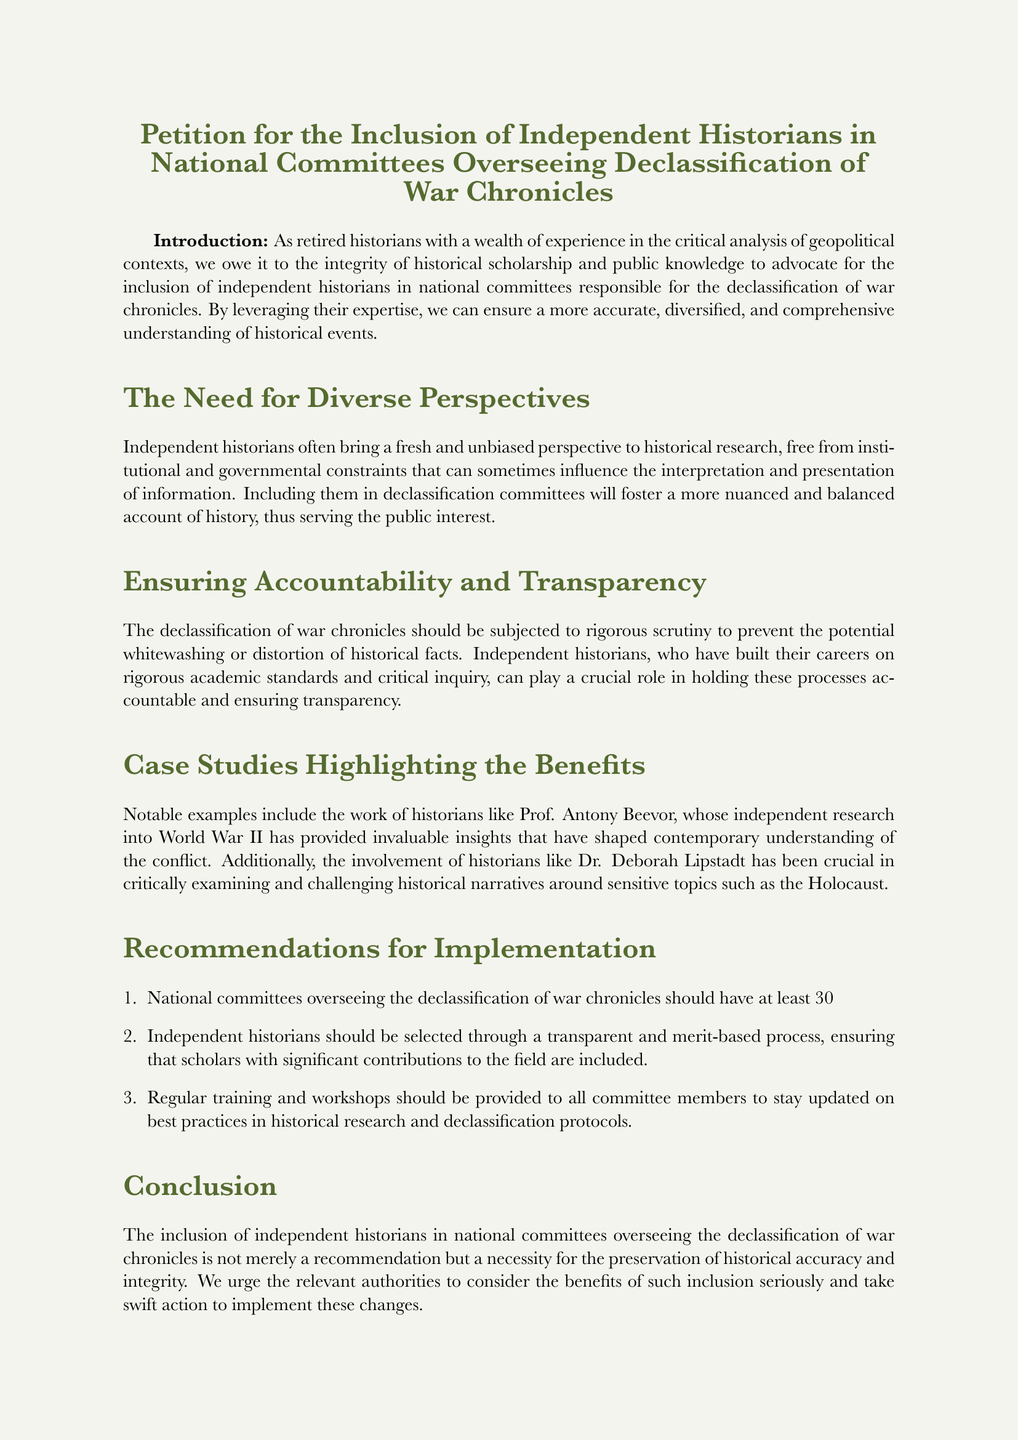What is the title of the petition? The title of the petition as mentioned in the document is a direct phrasing found at the beginning.
Answer: Petition for the Inclusion of Independent Historians in National Committees Overseeing Declassification of War Chronicles Who is the first signatory? The first signatory listed in the document is presented under the Signatories section.
Answer: Dr. Thomas Richardson What percentage of committee representation is recommended for independent historians? The document specifies a particular percentage in the recommendations made for the committees.
Answer: 30% Which historian is mentioned as an example of independent research? The document provides a name in its case studies discussing significant contributions to historical understanding.
Answer: Prof. Antony Beevor What is the primary goal of including independent historians in the committees? The introduction outlines the main purpose for advocating their inclusion.
Answer: Historical accuracy and integrity What kind of process is suggested for selecting independent historians? The recommendations section advises on the method through which independent historians should be chosen for the committees.
Answer: Transparent and merit-based process Which historical topic is Dr. Deborah Lipstadt associated with? The document highlights her involvement in examining a sensitive topic that connects with significant historical narratives.
Answer: The Holocaust 